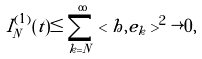Convert formula to latex. <formula><loc_0><loc_0><loc_500><loc_500>I _ { N } ^ { ( 1 ) } ( t ) \leq \sum _ { k = N } ^ { \infty } < h , e _ { k } > ^ { 2 } \rightarrow 0 ,</formula> 